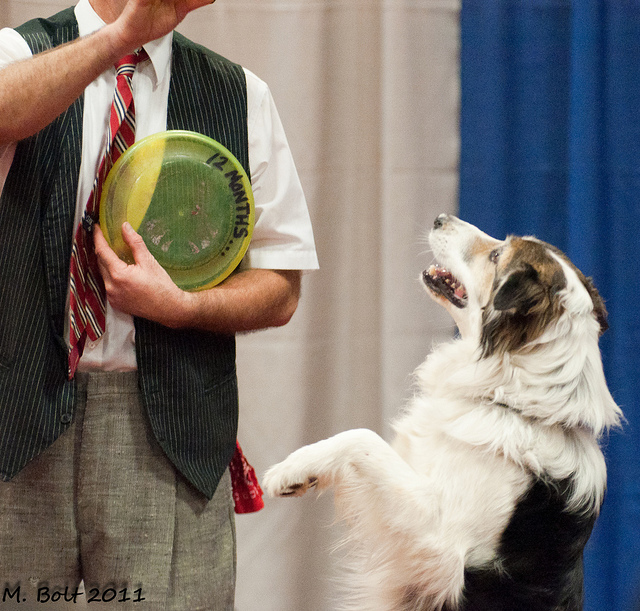Please transcribe the text in this image. 12 MONTHS M Bott 2011 